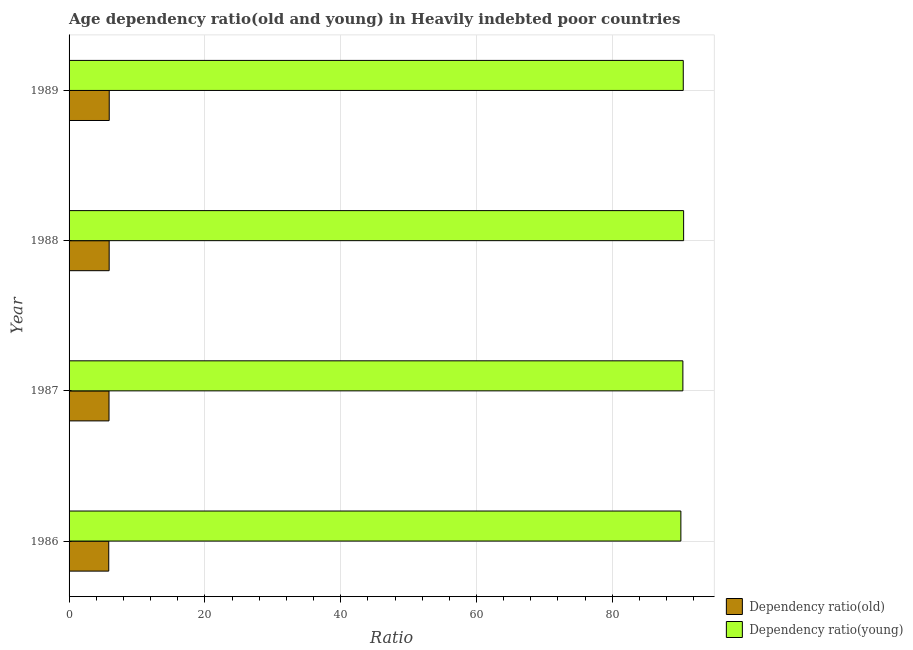How many different coloured bars are there?
Your answer should be very brief. 2. How many groups of bars are there?
Keep it short and to the point. 4. Are the number of bars per tick equal to the number of legend labels?
Your answer should be very brief. Yes. How many bars are there on the 2nd tick from the top?
Offer a very short reply. 2. In how many cases, is the number of bars for a given year not equal to the number of legend labels?
Keep it short and to the point. 0. What is the age dependency ratio(old) in 1987?
Provide a short and direct response. 5.88. Across all years, what is the maximum age dependency ratio(young)?
Keep it short and to the point. 90.5. Across all years, what is the minimum age dependency ratio(old)?
Provide a succinct answer. 5.84. In which year was the age dependency ratio(old) maximum?
Your response must be concise. 1989. In which year was the age dependency ratio(old) minimum?
Offer a terse response. 1986. What is the total age dependency ratio(young) in the graph?
Offer a very short reply. 361.45. What is the difference between the age dependency ratio(old) in 1988 and that in 1989?
Keep it short and to the point. -0.01. What is the difference between the age dependency ratio(young) in 1987 and the age dependency ratio(old) in 1988?
Provide a succinct answer. 84.49. What is the average age dependency ratio(old) per year?
Give a very brief answer. 5.89. In the year 1988, what is the difference between the age dependency ratio(young) and age dependency ratio(old)?
Make the answer very short. 84.6. Is the difference between the age dependency ratio(old) in 1988 and 1989 greater than the difference between the age dependency ratio(young) in 1988 and 1989?
Offer a terse response. No. What is the difference between the highest and the second highest age dependency ratio(young)?
Offer a very short reply. 0.05. What is the difference between the highest and the lowest age dependency ratio(old)?
Your answer should be compact. 0.07. Is the sum of the age dependency ratio(young) in 1987 and 1989 greater than the maximum age dependency ratio(old) across all years?
Your response must be concise. Yes. What does the 1st bar from the top in 1989 represents?
Provide a succinct answer. Dependency ratio(young). What does the 1st bar from the bottom in 1989 represents?
Your response must be concise. Dependency ratio(old). How many bars are there?
Provide a succinct answer. 8. Are all the bars in the graph horizontal?
Give a very brief answer. Yes. How many years are there in the graph?
Give a very brief answer. 4. Does the graph contain grids?
Provide a short and direct response. Yes. Where does the legend appear in the graph?
Your response must be concise. Bottom right. What is the title of the graph?
Give a very brief answer. Age dependency ratio(old and young) in Heavily indebted poor countries. Does "ODA received" appear as one of the legend labels in the graph?
Give a very brief answer. No. What is the label or title of the X-axis?
Make the answer very short. Ratio. What is the Ratio of Dependency ratio(old) in 1986?
Offer a terse response. 5.84. What is the Ratio in Dependency ratio(young) in 1986?
Your response must be concise. 90.1. What is the Ratio of Dependency ratio(old) in 1987?
Provide a short and direct response. 5.88. What is the Ratio in Dependency ratio(young) in 1987?
Your answer should be compact. 90.39. What is the Ratio of Dependency ratio(old) in 1988?
Keep it short and to the point. 5.91. What is the Ratio of Dependency ratio(young) in 1988?
Keep it short and to the point. 90.5. What is the Ratio of Dependency ratio(old) in 1989?
Your response must be concise. 5.92. What is the Ratio of Dependency ratio(young) in 1989?
Your response must be concise. 90.45. Across all years, what is the maximum Ratio in Dependency ratio(old)?
Offer a very short reply. 5.92. Across all years, what is the maximum Ratio of Dependency ratio(young)?
Provide a succinct answer. 90.5. Across all years, what is the minimum Ratio of Dependency ratio(old)?
Keep it short and to the point. 5.84. Across all years, what is the minimum Ratio in Dependency ratio(young)?
Offer a terse response. 90.1. What is the total Ratio of Dependency ratio(old) in the graph?
Provide a short and direct response. 23.55. What is the total Ratio in Dependency ratio(young) in the graph?
Offer a terse response. 361.45. What is the difference between the Ratio of Dependency ratio(old) in 1986 and that in 1987?
Your response must be concise. -0.04. What is the difference between the Ratio of Dependency ratio(young) in 1986 and that in 1987?
Your answer should be very brief. -0.29. What is the difference between the Ratio of Dependency ratio(old) in 1986 and that in 1988?
Provide a succinct answer. -0.06. What is the difference between the Ratio of Dependency ratio(young) in 1986 and that in 1988?
Offer a terse response. -0.4. What is the difference between the Ratio of Dependency ratio(old) in 1986 and that in 1989?
Offer a terse response. -0.07. What is the difference between the Ratio in Dependency ratio(young) in 1986 and that in 1989?
Your answer should be compact. -0.35. What is the difference between the Ratio in Dependency ratio(old) in 1987 and that in 1988?
Your response must be concise. -0.02. What is the difference between the Ratio of Dependency ratio(young) in 1987 and that in 1988?
Your answer should be very brief. -0.11. What is the difference between the Ratio in Dependency ratio(old) in 1987 and that in 1989?
Your answer should be very brief. -0.03. What is the difference between the Ratio of Dependency ratio(young) in 1987 and that in 1989?
Provide a short and direct response. -0.06. What is the difference between the Ratio in Dependency ratio(old) in 1988 and that in 1989?
Give a very brief answer. -0.01. What is the difference between the Ratio of Dependency ratio(young) in 1988 and that in 1989?
Your answer should be compact. 0.05. What is the difference between the Ratio of Dependency ratio(old) in 1986 and the Ratio of Dependency ratio(young) in 1987?
Make the answer very short. -84.55. What is the difference between the Ratio of Dependency ratio(old) in 1986 and the Ratio of Dependency ratio(young) in 1988?
Make the answer very short. -84.66. What is the difference between the Ratio in Dependency ratio(old) in 1986 and the Ratio in Dependency ratio(young) in 1989?
Offer a very short reply. -84.61. What is the difference between the Ratio of Dependency ratio(old) in 1987 and the Ratio of Dependency ratio(young) in 1988?
Provide a succinct answer. -84.62. What is the difference between the Ratio of Dependency ratio(old) in 1987 and the Ratio of Dependency ratio(young) in 1989?
Your response must be concise. -84.57. What is the difference between the Ratio of Dependency ratio(old) in 1988 and the Ratio of Dependency ratio(young) in 1989?
Provide a short and direct response. -84.55. What is the average Ratio in Dependency ratio(old) per year?
Provide a succinct answer. 5.89. What is the average Ratio of Dependency ratio(young) per year?
Your response must be concise. 90.36. In the year 1986, what is the difference between the Ratio in Dependency ratio(old) and Ratio in Dependency ratio(young)?
Provide a short and direct response. -84.26. In the year 1987, what is the difference between the Ratio of Dependency ratio(old) and Ratio of Dependency ratio(young)?
Offer a terse response. -84.51. In the year 1988, what is the difference between the Ratio in Dependency ratio(old) and Ratio in Dependency ratio(young)?
Your answer should be very brief. -84.6. In the year 1989, what is the difference between the Ratio in Dependency ratio(old) and Ratio in Dependency ratio(young)?
Provide a short and direct response. -84.54. What is the ratio of the Ratio in Dependency ratio(young) in 1986 to that in 1987?
Offer a terse response. 1. What is the ratio of the Ratio of Dependency ratio(old) in 1986 to that in 1988?
Provide a succinct answer. 0.99. What is the ratio of the Ratio of Dependency ratio(young) in 1986 to that in 1988?
Keep it short and to the point. 1. What is the ratio of the Ratio of Dependency ratio(young) in 1986 to that in 1989?
Offer a very short reply. 1. What is the ratio of the Ratio of Dependency ratio(old) in 1987 to that in 1988?
Give a very brief answer. 1. What is the ratio of the Ratio in Dependency ratio(young) in 1987 to that in 1989?
Your response must be concise. 1. What is the ratio of the Ratio of Dependency ratio(old) in 1988 to that in 1989?
Keep it short and to the point. 1. What is the ratio of the Ratio of Dependency ratio(young) in 1988 to that in 1989?
Give a very brief answer. 1. What is the difference between the highest and the second highest Ratio of Dependency ratio(old)?
Offer a very short reply. 0.01. What is the difference between the highest and the second highest Ratio in Dependency ratio(young)?
Make the answer very short. 0.05. What is the difference between the highest and the lowest Ratio of Dependency ratio(old)?
Provide a succinct answer. 0.07. What is the difference between the highest and the lowest Ratio in Dependency ratio(young)?
Ensure brevity in your answer.  0.4. 